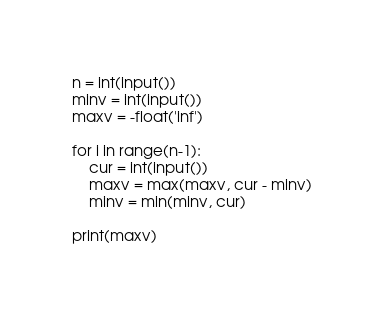Convert code to text. <code><loc_0><loc_0><loc_500><loc_500><_Python_>n = int(input())
minv = int(input())
maxv = -float('inf')

for i in range(n-1):
    cur = int(input())
    maxv = max(maxv, cur - minv)
    minv = min(minv, cur)

print(maxv)
    
</code> 